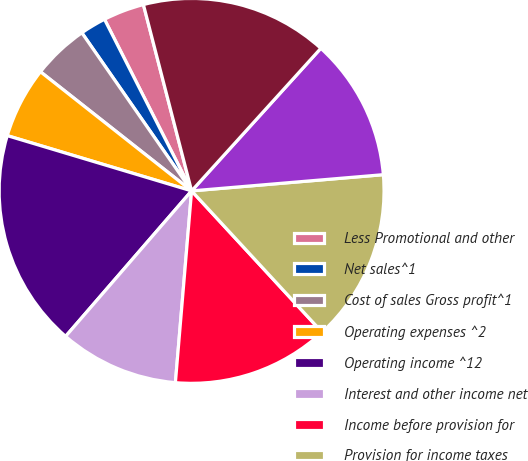Convert chart. <chart><loc_0><loc_0><loc_500><loc_500><pie_chart><fcel>Less Promotional and other<fcel>Net sales^1<fcel>Cost of sales Gross profit^1<fcel>Operating expenses ^2<fcel>Operating income ^12<fcel>Interest and other income net<fcel>Income before provision for<fcel>Provision for income taxes<fcel>Net income<fcel>Basic<nl><fcel>3.45%<fcel>2.18%<fcel>4.72%<fcel>5.99%<fcel>18.28%<fcel>10.02%<fcel>13.21%<fcel>14.48%<fcel>11.94%<fcel>15.75%<nl></chart> 